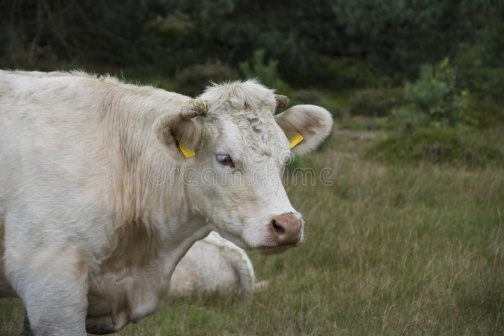How does the presence of the cow enhance the landscape's overall aesthetic? The presence of the cow adds a dynamic element to the otherwise still landscape, bringing life to the scene. It highlights the symbiotic relationship between livestock and rural landscapes, where animals contribute to the maintenance of the land through grazing. Visually, the white of the cow contrasts with the rich greens of the field, creating a picturesque, pastoral scene that embodies tranquility and the beauty of rural life. 